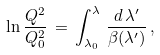Convert formula to latex. <formula><loc_0><loc_0><loc_500><loc_500>\ln \frac { Q ^ { 2 } } { Q _ { 0 } ^ { 2 } } \, = \, \int _ { { \lambda } _ { 0 } } ^ { \lambda } \, \frac { d \, { \lambda } ^ { \prime } } { { \beta } ( { \lambda } ^ { \prime } ) } \, ,</formula> 